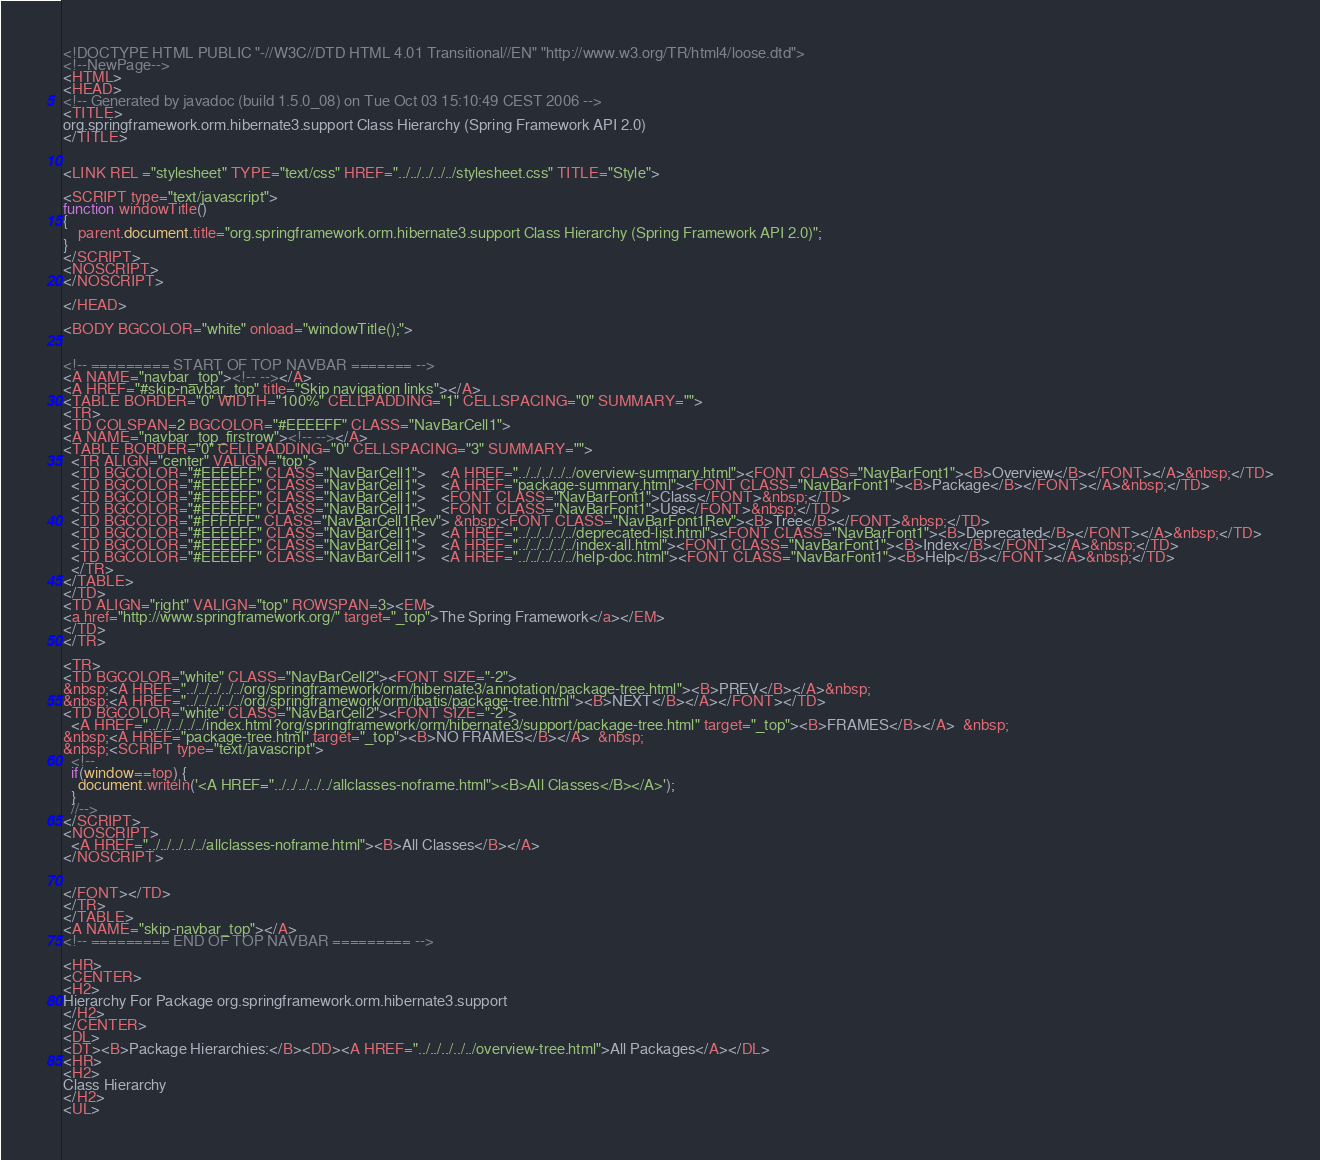<code> <loc_0><loc_0><loc_500><loc_500><_HTML_><!DOCTYPE HTML PUBLIC "-//W3C//DTD HTML 4.01 Transitional//EN" "http://www.w3.org/TR/html4/loose.dtd">
<!--NewPage-->
<HTML>
<HEAD>
<!-- Generated by javadoc (build 1.5.0_08) on Tue Oct 03 15:10:49 CEST 2006 -->
<TITLE>
org.springframework.orm.hibernate3.support Class Hierarchy (Spring Framework API 2.0)
</TITLE>


<LINK REL ="stylesheet" TYPE="text/css" HREF="../../../../../stylesheet.css" TITLE="Style">

<SCRIPT type="text/javascript">
function windowTitle()
{
    parent.document.title="org.springframework.orm.hibernate3.support Class Hierarchy (Spring Framework API 2.0)";
}
</SCRIPT>
<NOSCRIPT>
</NOSCRIPT>

</HEAD>

<BODY BGCOLOR="white" onload="windowTitle();">


<!-- ========= START OF TOP NAVBAR ======= -->
<A NAME="navbar_top"><!-- --></A>
<A HREF="#skip-navbar_top" title="Skip navigation links"></A>
<TABLE BORDER="0" WIDTH="100%" CELLPADDING="1" CELLSPACING="0" SUMMARY="">
<TR>
<TD COLSPAN=2 BGCOLOR="#EEEEFF" CLASS="NavBarCell1">
<A NAME="navbar_top_firstrow"><!-- --></A>
<TABLE BORDER="0" CELLPADDING="0" CELLSPACING="3" SUMMARY="">
  <TR ALIGN="center" VALIGN="top">
  <TD BGCOLOR="#EEEEFF" CLASS="NavBarCell1">    <A HREF="../../../../../overview-summary.html"><FONT CLASS="NavBarFont1"><B>Overview</B></FONT></A>&nbsp;</TD>
  <TD BGCOLOR="#EEEEFF" CLASS="NavBarCell1">    <A HREF="package-summary.html"><FONT CLASS="NavBarFont1"><B>Package</B></FONT></A>&nbsp;</TD>
  <TD BGCOLOR="#EEEEFF" CLASS="NavBarCell1">    <FONT CLASS="NavBarFont1">Class</FONT>&nbsp;</TD>
  <TD BGCOLOR="#EEEEFF" CLASS="NavBarCell1">    <FONT CLASS="NavBarFont1">Use</FONT>&nbsp;</TD>
  <TD BGCOLOR="#FFFFFF" CLASS="NavBarCell1Rev"> &nbsp;<FONT CLASS="NavBarFont1Rev"><B>Tree</B></FONT>&nbsp;</TD>
  <TD BGCOLOR="#EEEEFF" CLASS="NavBarCell1">    <A HREF="../../../../../deprecated-list.html"><FONT CLASS="NavBarFont1"><B>Deprecated</B></FONT></A>&nbsp;</TD>
  <TD BGCOLOR="#EEEEFF" CLASS="NavBarCell1">    <A HREF="../../../../../index-all.html"><FONT CLASS="NavBarFont1"><B>Index</B></FONT></A>&nbsp;</TD>
  <TD BGCOLOR="#EEEEFF" CLASS="NavBarCell1">    <A HREF="../../../../../help-doc.html"><FONT CLASS="NavBarFont1"><B>Help</B></FONT></A>&nbsp;</TD>
  </TR>
</TABLE>
</TD>
<TD ALIGN="right" VALIGN="top" ROWSPAN=3><EM>
<a href="http://www.springframework.org/" target="_top">The Spring Framework</a></EM>
</TD>
</TR>

<TR>
<TD BGCOLOR="white" CLASS="NavBarCell2"><FONT SIZE="-2">
&nbsp;<A HREF="../../../../../org/springframework/orm/hibernate3/annotation/package-tree.html"><B>PREV</B></A>&nbsp;
&nbsp;<A HREF="../../../../../org/springframework/orm/ibatis/package-tree.html"><B>NEXT</B></A></FONT></TD>
<TD BGCOLOR="white" CLASS="NavBarCell2"><FONT SIZE="-2">
  <A HREF="../../../../../index.html?org/springframework/orm/hibernate3/support/package-tree.html" target="_top"><B>FRAMES</B></A>  &nbsp;
&nbsp;<A HREF="package-tree.html" target="_top"><B>NO FRAMES</B></A>  &nbsp;
&nbsp;<SCRIPT type="text/javascript">
  <!--
  if(window==top) {
    document.writeln('<A HREF="../../../../../allclasses-noframe.html"><B>All Classes</B></A>');
  }
  //-->
</SCRIPT>
<NOSCRIPT>
  <A HREF="../../../../../allclasses-noframe.html"><B>All Classes</B></A>
</NOSCRIPT>


</FONT></TD>
</TR>
</TABLE>
<A NAME="skip-navbar_top"></A>
<!-- ========= END OF TOP NAVBAR ========= -->

<HR>
<CENTER>
<H2>
Hierarchy For Package org.springframework.orm.hibernate3.support
</H2>
</CENTER>
<DL>
<DT><B>Package Hierarchies:</B><DD><A HREF="../../../../../overview-tree.html">All Packages</A></DL>
<HR>
<H2>
Class Hierarchy
</H2>
<UL></code> 